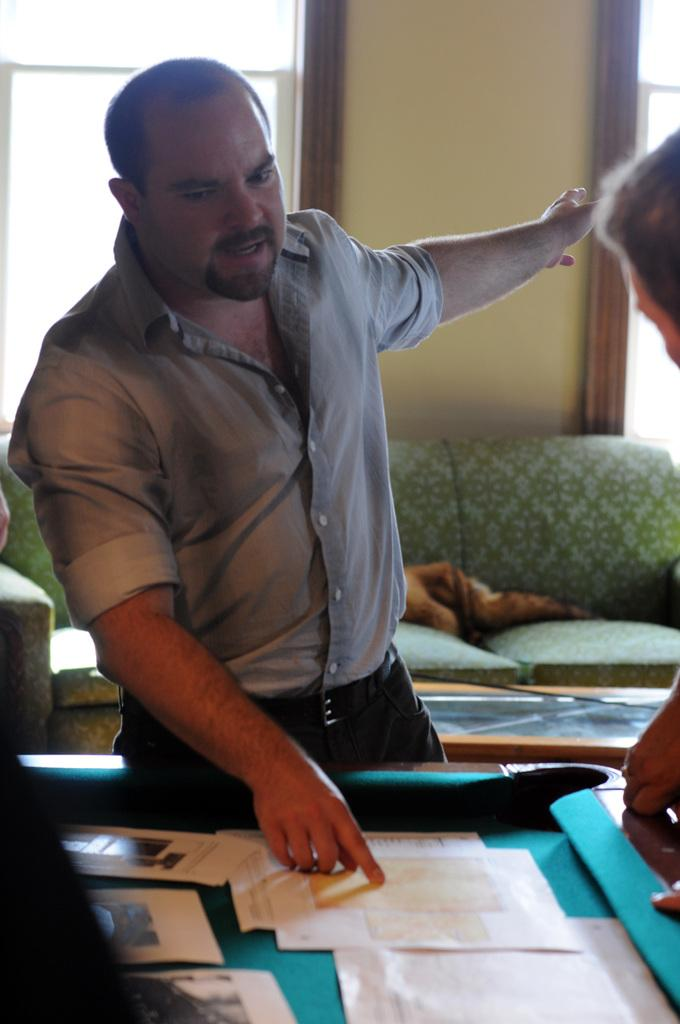Who is present in the image? There is a man in the image. What is the man doing in the image? The man is standing in front of a table and holding a paper. What is located behind the table in the image? There is a sofa behind the table. What type of chain is the man wearing in the image? There is no chain visible on the man in the image. 